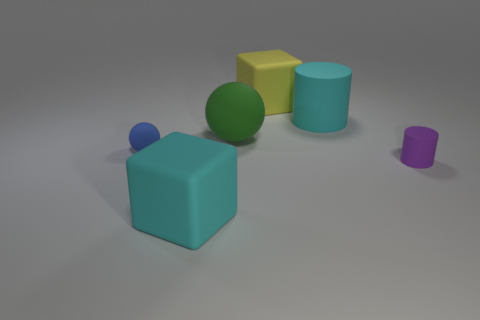Add 2 large green rubber objects. How many objects exist? 8 Subtract all balls. How many objects are left? 4 Add 5 big yellow metallic things. How many big yellow metallic things exist? 5 Subtract 0 brown blocks. How many objects are left? 6 Subtract all tiny rubber cylinders. Subtract all small cyan metal cubes. How many objects are left? 5 Add 6 tiny purple matte things. How many tiny purple matte things are left? 7 